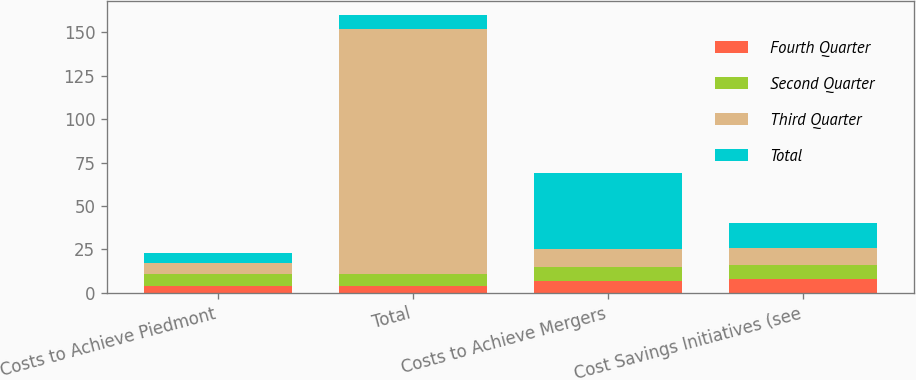Convert chart. <chart><loc_0><loc_0><loc_500><loc_500><stacked_bar_chart><ecel><fcel>Costs to Achieve Piedmont<fcel>Total<fcel>Costs to Achieve Mergers<fcel>Cost Savings Initiatives (see<nl><fcel>Fourth Quarter<fcel>4<fcel>4<fcel>7<fcel>8<nl><fcel>Second Quarter<fcel>7<fcel>7<fcel>8<fcel>8<nl><fcel>Third Quarter<fcel>6<fcel>141<fcel>10<fcel>10<nl><fcel>Total<fcel>6<fcel>8<fcel>44<fcel>14<nl></chart> 